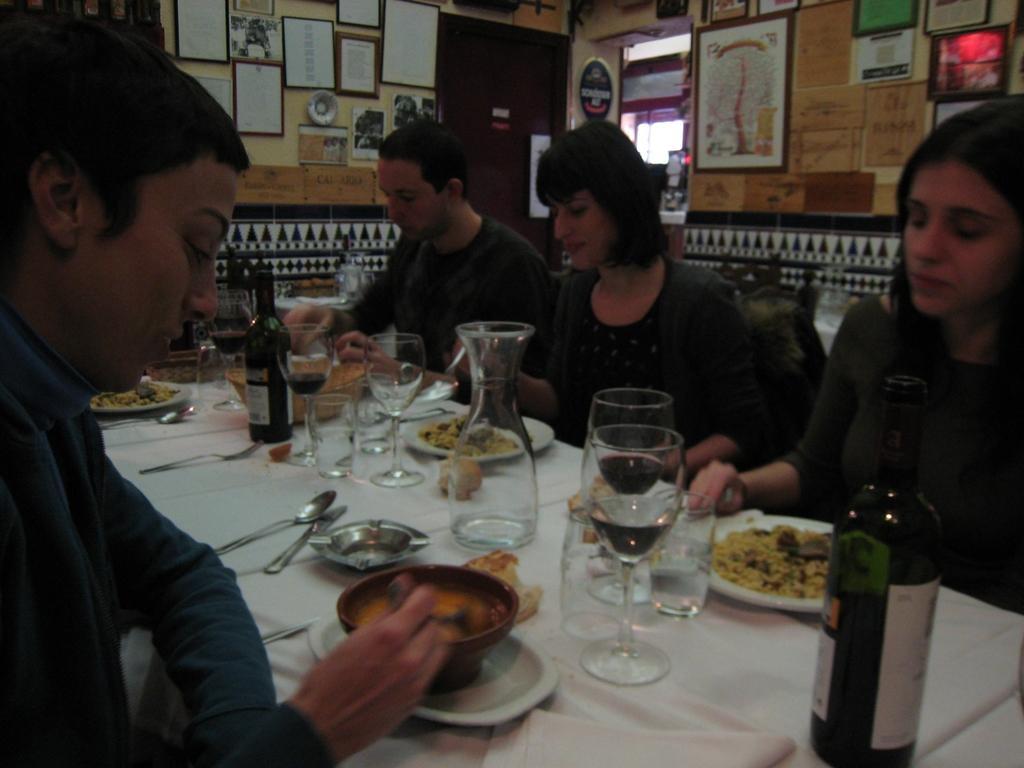In one or two sentences, can you explain what this image depicts? In this picture there are four person sitting on a chair. On table there is a bottle, glass, mug, plate, food and a bowl apart from that there is a spoon, knife, tissue paper and plate. In the top right there is a photo frames. And on the top we can see a window beside that there is a door. 